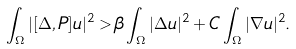<formula> <loc_0><loc_0><loc_500><loc_500>\int _ { \Omega } | [ \Delta , P ] u | ^ { 2 } > \beta \int _ { \Omega } | \Delta u | ^ { 2 } + C \int _ { \Omega } | \nabla u | ^ { 2 } .</formula> 